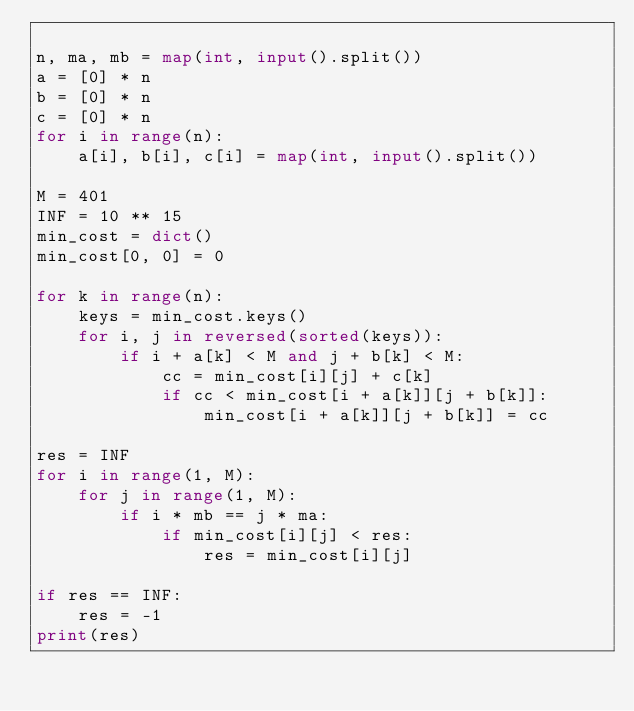<code> <loc_0><loc_0><loc_500><loc_500><_Python_>
n, ma, mb = map(int, input().split())
a = [0] * n
b = [0] * n
c = [0] * n
for i in range(n):
    a[i], b[i], c[i] = map(int, input().split())

M = 401
INF = 10 ** 15
min_cost = dict()
min_cost[0, 0] = 0

for k in range(n):
    keys = min_cost.keys()
    for i, j in reversed(sorted(keys)):
        if i + a[k] < M and j + b[k] < M:
            cc = min_cost[i][j] + c[k]
            if cc < min_cost[i + a[k]][j + b[k]]:
                min_cost[i + a[k]][j + b[k]] = cc

res = INF
for i in range(1, M):
    for j in range(1, M):
        if i * mb == j * ma:
            if min_cost[i][j] < res:
                res = min_cost[i][j]

if res == INF:
    res = -1
print(res)</code> 